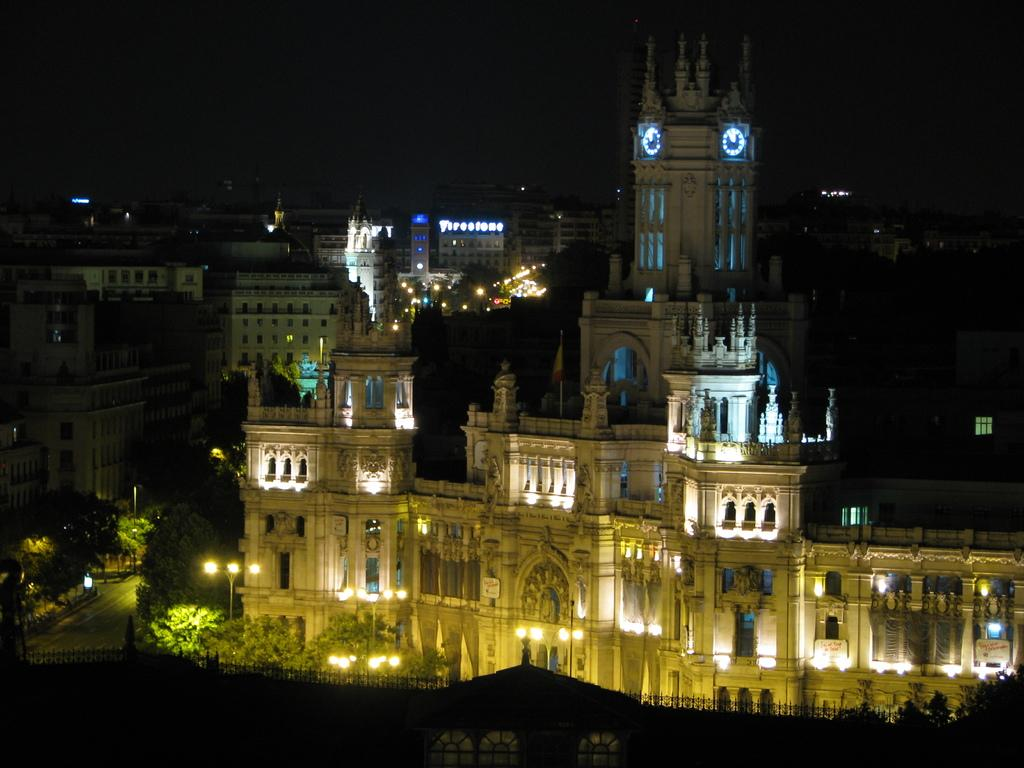What can be seen in the image that provides illumination? There are lights in the image. What type of structures are visible in the image? There are buildings in the image. What type of vegetation is present in the image? There are trees in the image. What is visible at the top of the image? The sky is visible at the top of the image. What degree does the mother have in the image? There is no mention of a mother or a degree in the image. What type of waves can be seen in the image? There are no waves present in the image. 